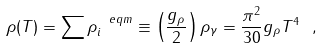<formula> <loc_0><loc_0><loc_500><loc_500>\rho ( T ) = \sum \rho ^ { \ e q m } _ { i } \equiv \left ( \frac { g _ { \rho } } { 2 } \right ) \rho _ { \gamma } = \frac { \pi ^ { 2 } } { 3 0 } g _ { \rho } T ^ { 4 } \ ,</formula> 